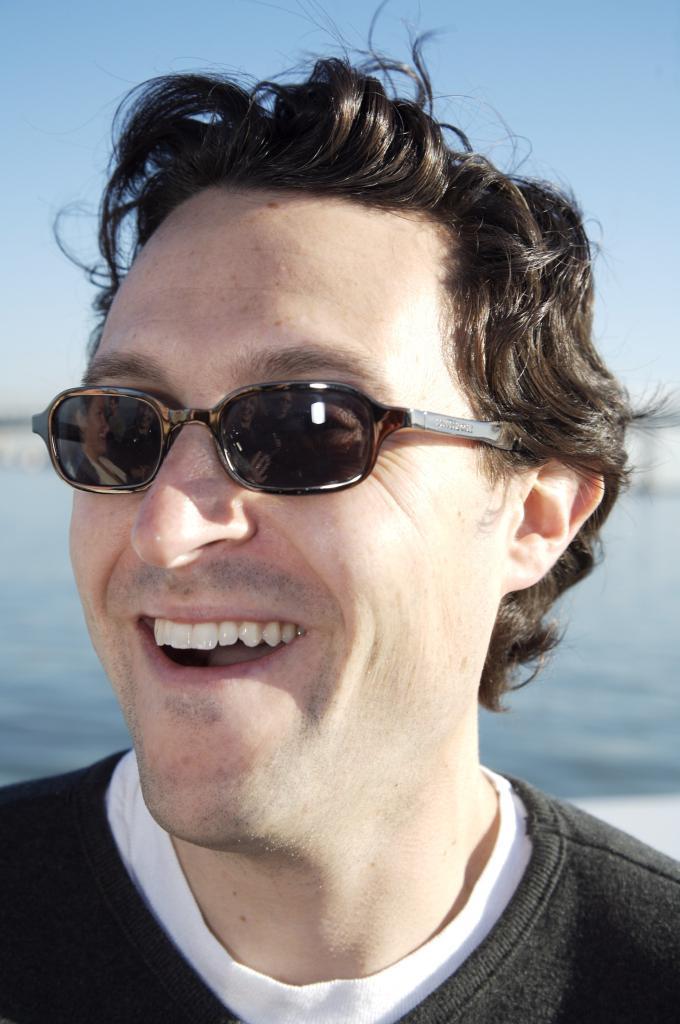Describe this image in one or two sentences. This is a zoomed in picture. In the foreground there is a man wearing a black color t-shirt, goggles, smiling and seems to be standing. In the background we can see the sky and a water body. 